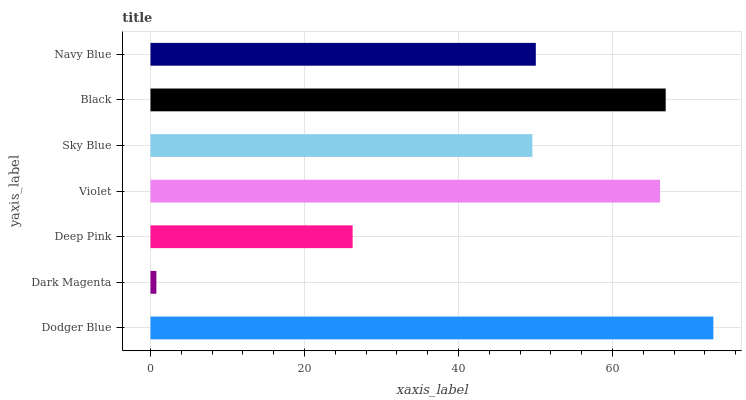Is Dark Magenta the minimum?
Answer yes or no. Yes. Is Dodger Blue the maximum?
Answer yes or no. Yes. Is Deep Pink the minimum?
Answer yes or no. No. Is Deep Pink the maximum?
Answer yes or no. No. Is Deep Pink greater than Dark Magenta?
Answer yes or no. Yes. Is Dark Magenta less than Deep Pink?
Answer yes or no. Yes. Is Dark Magenta greater than Deep Pink?
Answer yes or no. No. Is Deep Pink less than Dark Magenta?
Answer yes or no. No. Is Navy Blue the high median?
Answer yes or no. Yes. Is Navy Blue the low median?
Answer yes or no. Yes. Is Deep Pink the high median?
Answer yes or no. No. Is Deep Pink the low median?
Answer yes or no. No. 